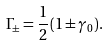<formula> <loc_0><loc_0><loc_500><loc_500>\Gamma _ { \pm } & = \frac { 1 } { 2 } ( 1 \pm \gamma _ { 0 } ) .</formula> 